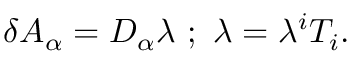Convert formula to latex. <formula><loc_0><loc_0><loc_500><loc_500>\delta A _ { \alpha } = D _ { \alpha } \lambda \, ; \, \lambda = \lambda ^ { i } T _ { i } .</formula> 